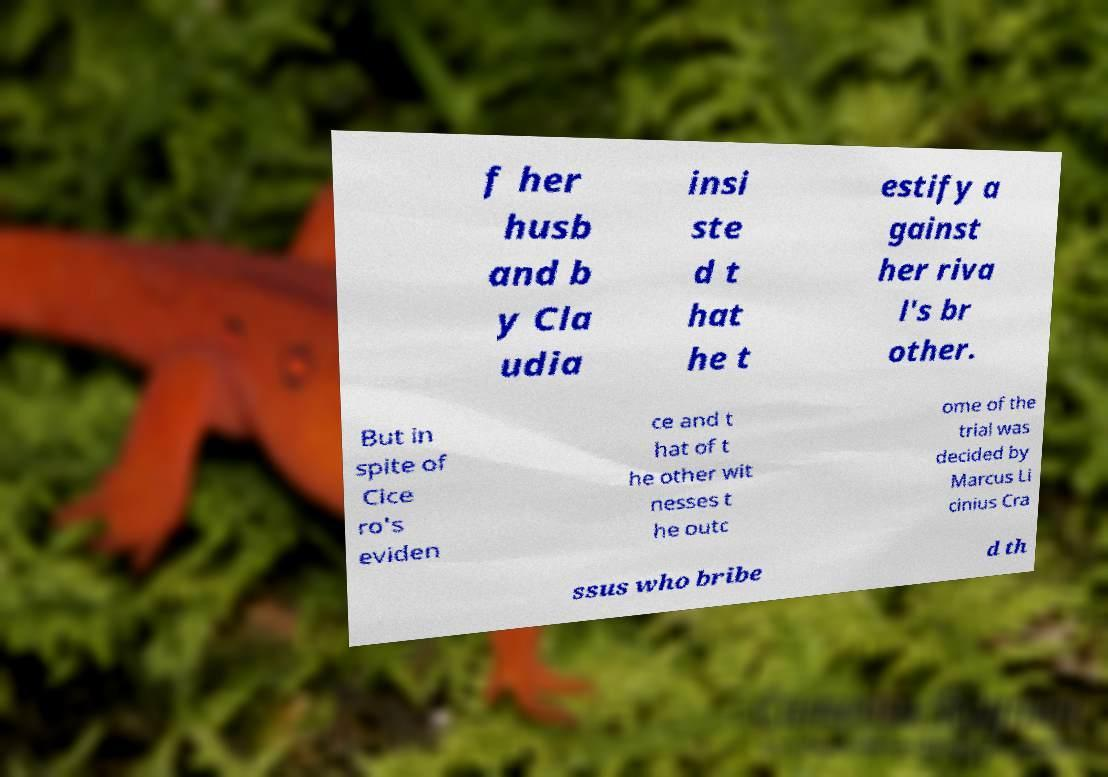There's text embedded in this image that I need extracted. Can you transcribe it verbatim? f her husb and b y Cla udia insi ste d t hat he t estify a gainst her riva l's br other. But in spite of Cice ro's eviden ce and t hat of t he other wit nesses t he outc ome of the trial was decided by Marcus Li cinius Cra ssus who bribe d th 